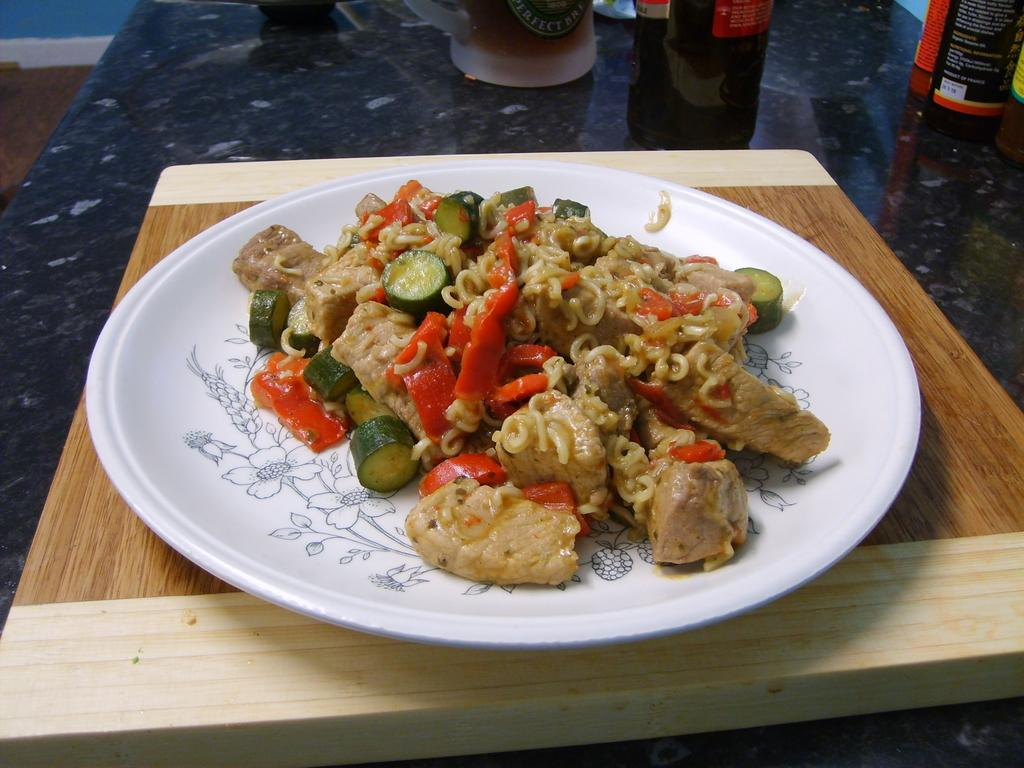What is on the plate that is visible in the image? There is food in a plate in the image. Where is the plate located in the image? The plate is on a wooden plank. What can be seen in the background of the image? There are bottles in the background of the image. How are the bottles positioned in the image? The bottles are truncated on a platform. What color is the crayon used to draw on the wooden plank in the image? There is no crayon present in the image, and therefore no such drawing can be observed. 